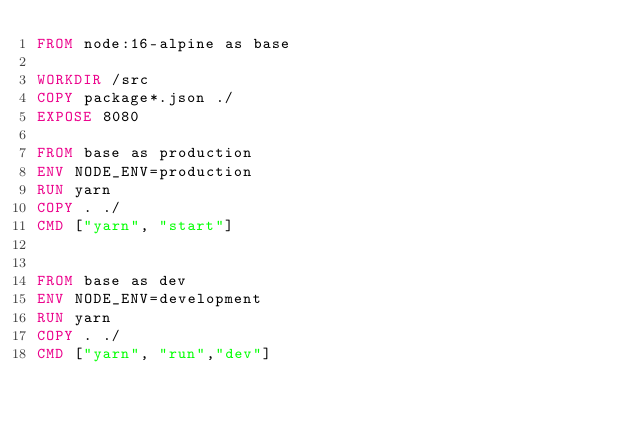<code> <loc_0><loc_0><loc_500><loc_500><_Dockerfile_>FROM node:16-alpine as base

WORKDIR /src
COPY package*.json ./
EXPOSE 8080

FROM base as production
ENV NODE_ENV=production
RUN yarn
COPY . ./
CMD ["yarn", "start"]


FROM base as dev
ENV NODE_ENV=development
RUN yarn
COPY . ./
CMD ["yarn", "run","dev"]
</code> 